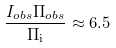Convert formula to latex. <formula><loc_0><loc_0><loc_500><loc_500>\frac { I _ { o b s } \Pi _ { o b s } } { \Pi _ { \mathrm i } } \approx 6 . 5</formula> 